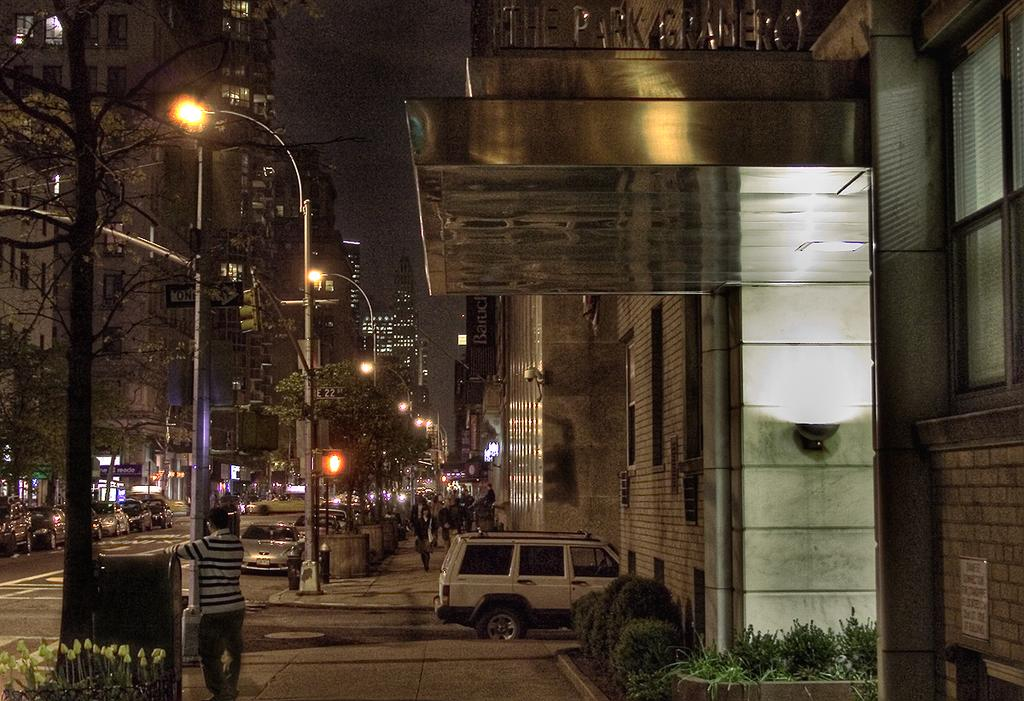What can be seen on the road in the image? There are vehicles on the road in the image. What type of natural elements are present in the image? There are plants, trees, and the sky visible in the image. What man-made structures can be seen in the image? There are poles, lights, boards, and buildings in the image. Are there any people present in the image? Yes, there are persons in the image. What type of bean is being grown in the image? There is no bean present in the image. Can you describe the donkey's expression in the image? There is no donkey present in the image. 